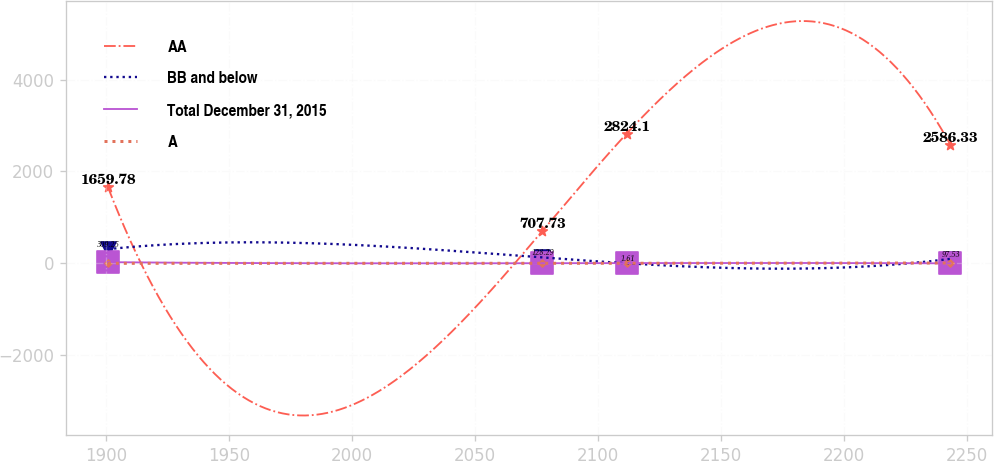Convert chart. <chart><loc_0><loc_0><loc_500><loc_500><line_chart><ecel><fcel>AA<fcel>BB and below<fcel>Total December 31, 2015<fcel>A<nl><fcel>1900.79<fcel>1659.78<fcel>309.25<fcel>25.84<fcel>0<nl><fcel>2077.39<fcel>707.73<fcel>128.29<fcel>2.58<fcel>0.76<nl><fcel>2111.62<fcel>2824.1<fcel>1.61<fcel>5.16<fcel>1.52<nl><fcel>2243.12<fcel>2586.33<fcel>97.53<fcel>0<fcel>7.55<nl></chart> 